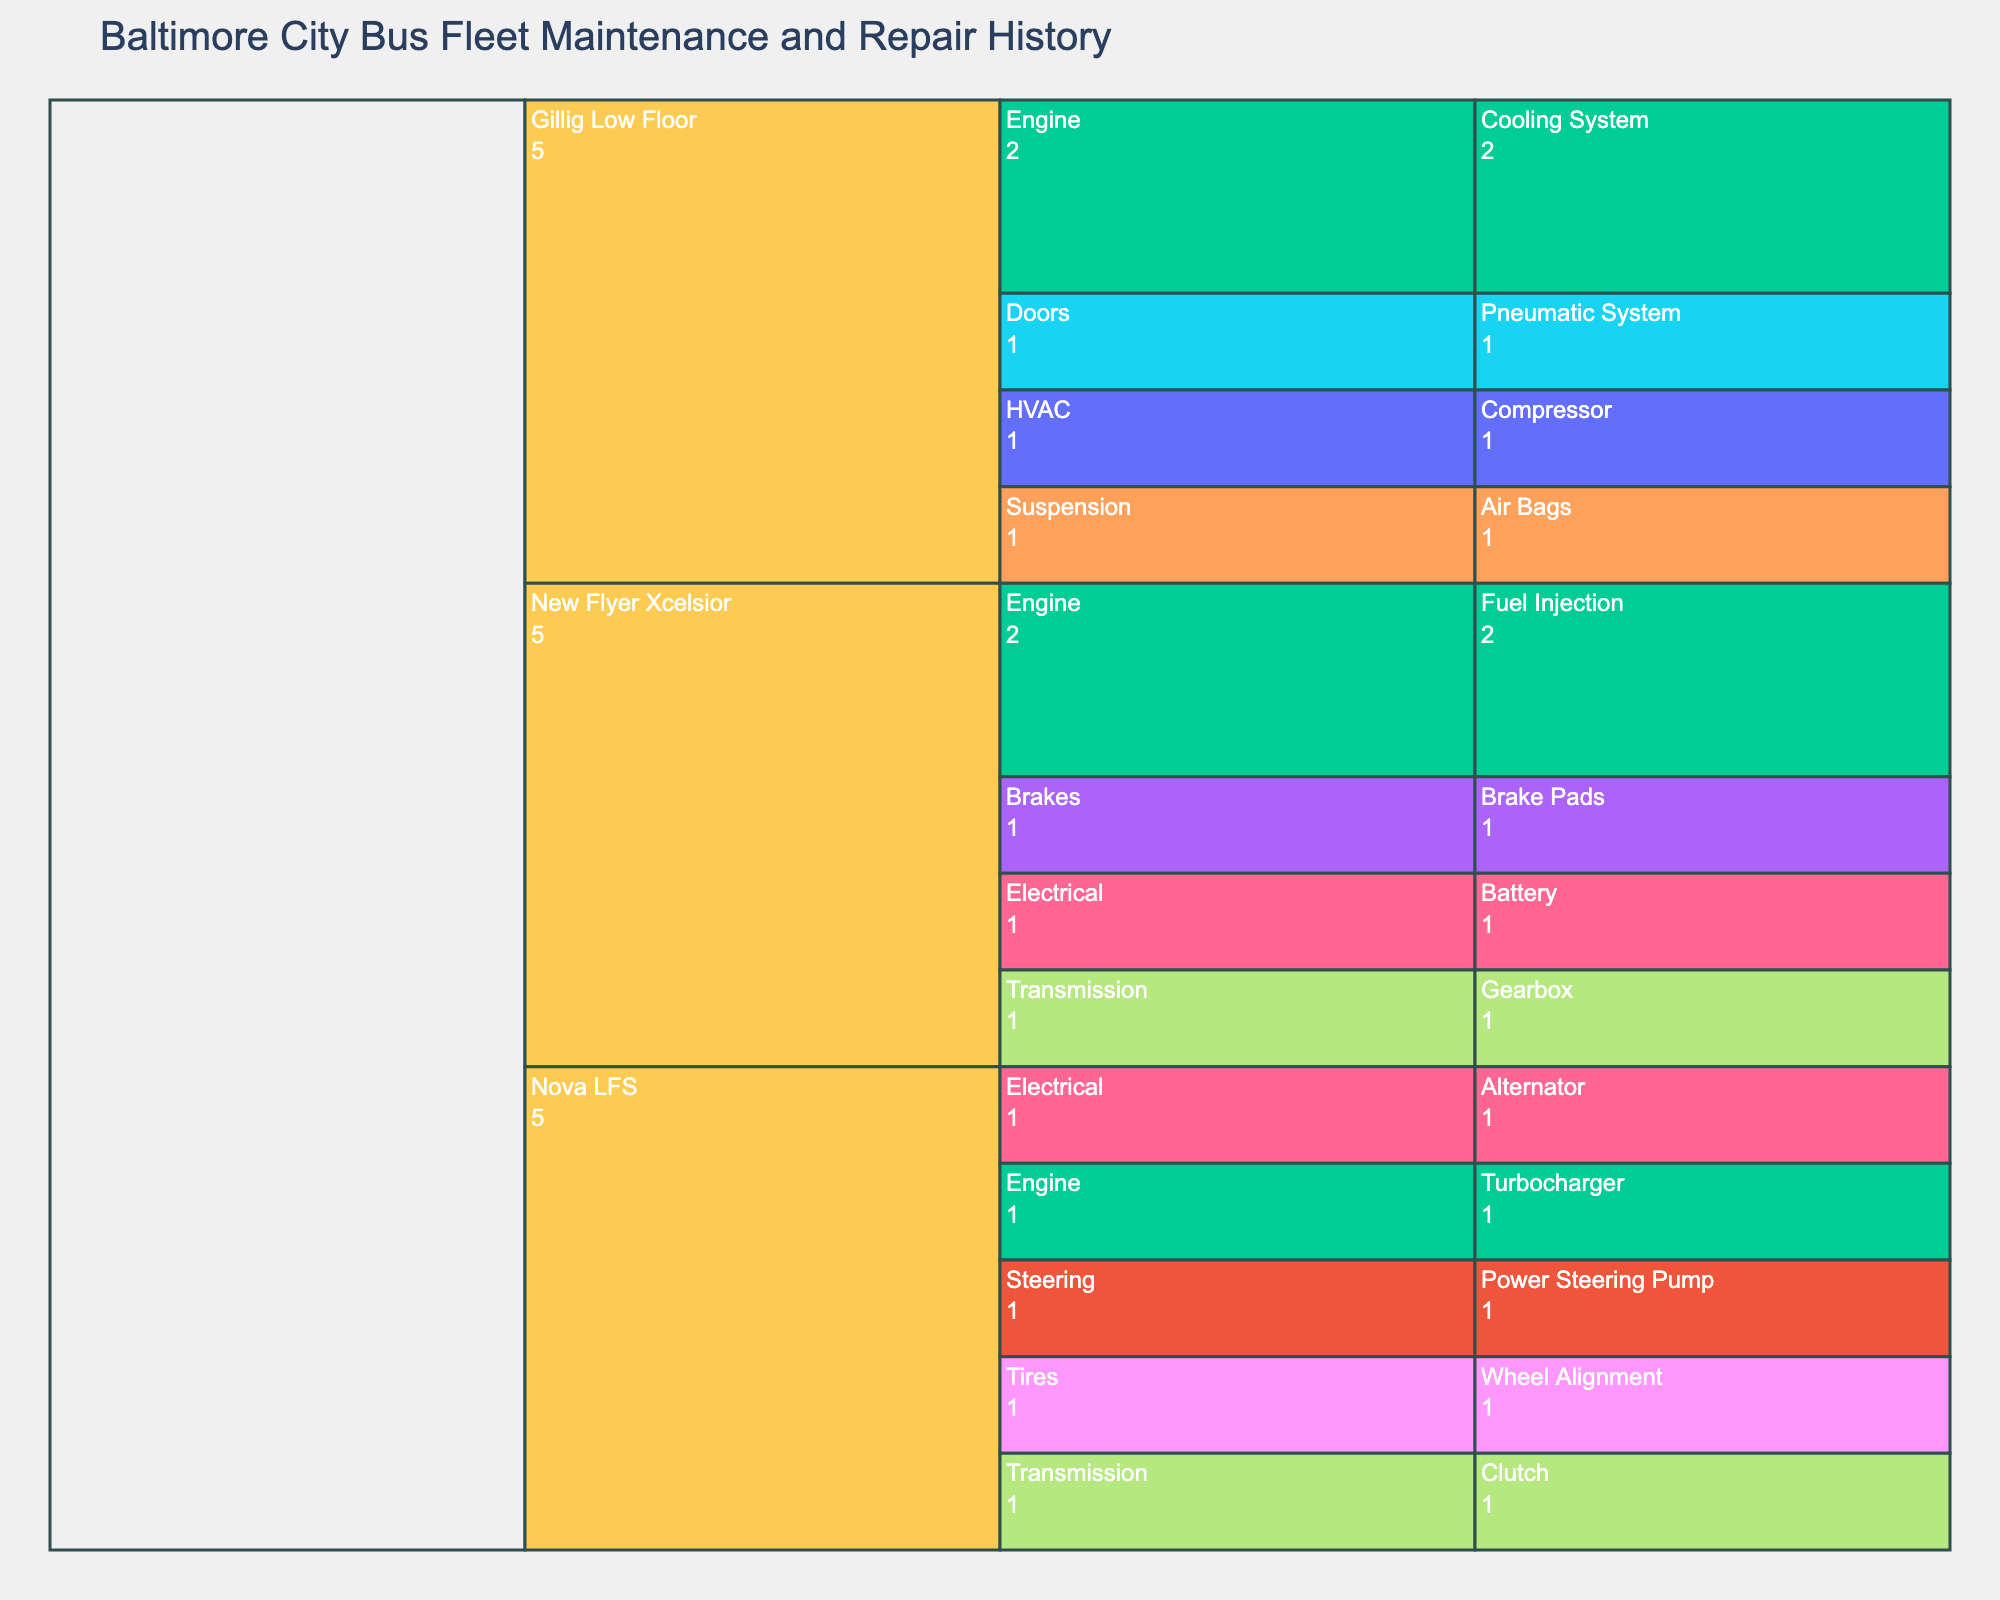What's the title of the figure? The title is displayed at the top of the figure, often giving a clear summary of what the chart is about. In this case, reading the title directly from the figure will provide the answer.
Answer: Baltimore City Bus Fleet Maintenance and Repair History Which bus model has the most maintenance issues recorded? Look for the bus model with the largest area or the most extensive branches in the Icicle Chart. This indicates the bus model with numerous issues.
Answer: New Flyer Xcelsior How many issues are related to the Engine system of the New Flyer Xcelsior model? Trace the path from "New Flyer Xcelsior" to "Engine" and count all terminal nodes (issues) under this branch.
Answer: 2 Among the three bus models, which one has the least variety of systems with recorded issues? Identify the bus model with the fewest branching systems directly beneath it.
Answer: Nova LFS Which system under the Gillig Low Floor model has the most components with recorded issues? Find the system within the Gillig Low Floor branch that has the most extensive branching to different components.
Answer: Engine How many different components have issues listed for the New Flyer Xcelsior? Trace the path from "New Flyer Xcelsior" and count the unique components listed under various systems.
Answer: 4 Compare the number of engine-related issues between the New Flyer Xcelsior and Nova LFS models. Which has more? Count the terminal nodes (issues) under the "Engine" system for both New Flyer Xcelsior and Nova LFS. Compare the counts.
Answer: New Flyer Xcelsior What type of issue is most common within the Brakes system of the New Flyer Xcelsior model? Look under the "Brakes" branch within the New Flyer Xcelsior and identify the terminal node (issue) listed there.
Answer: Wear and Tear How many unique systems register issues across the entire bus fleet? Count all unique systems (second level nodes) under all bus models.
Answer: 7 What's a common issue across multiple bus models and systems? Scan through the issues listed and identify any recurring ones across different models and systems, noting occurrences.
Answer: Fluid Leak 